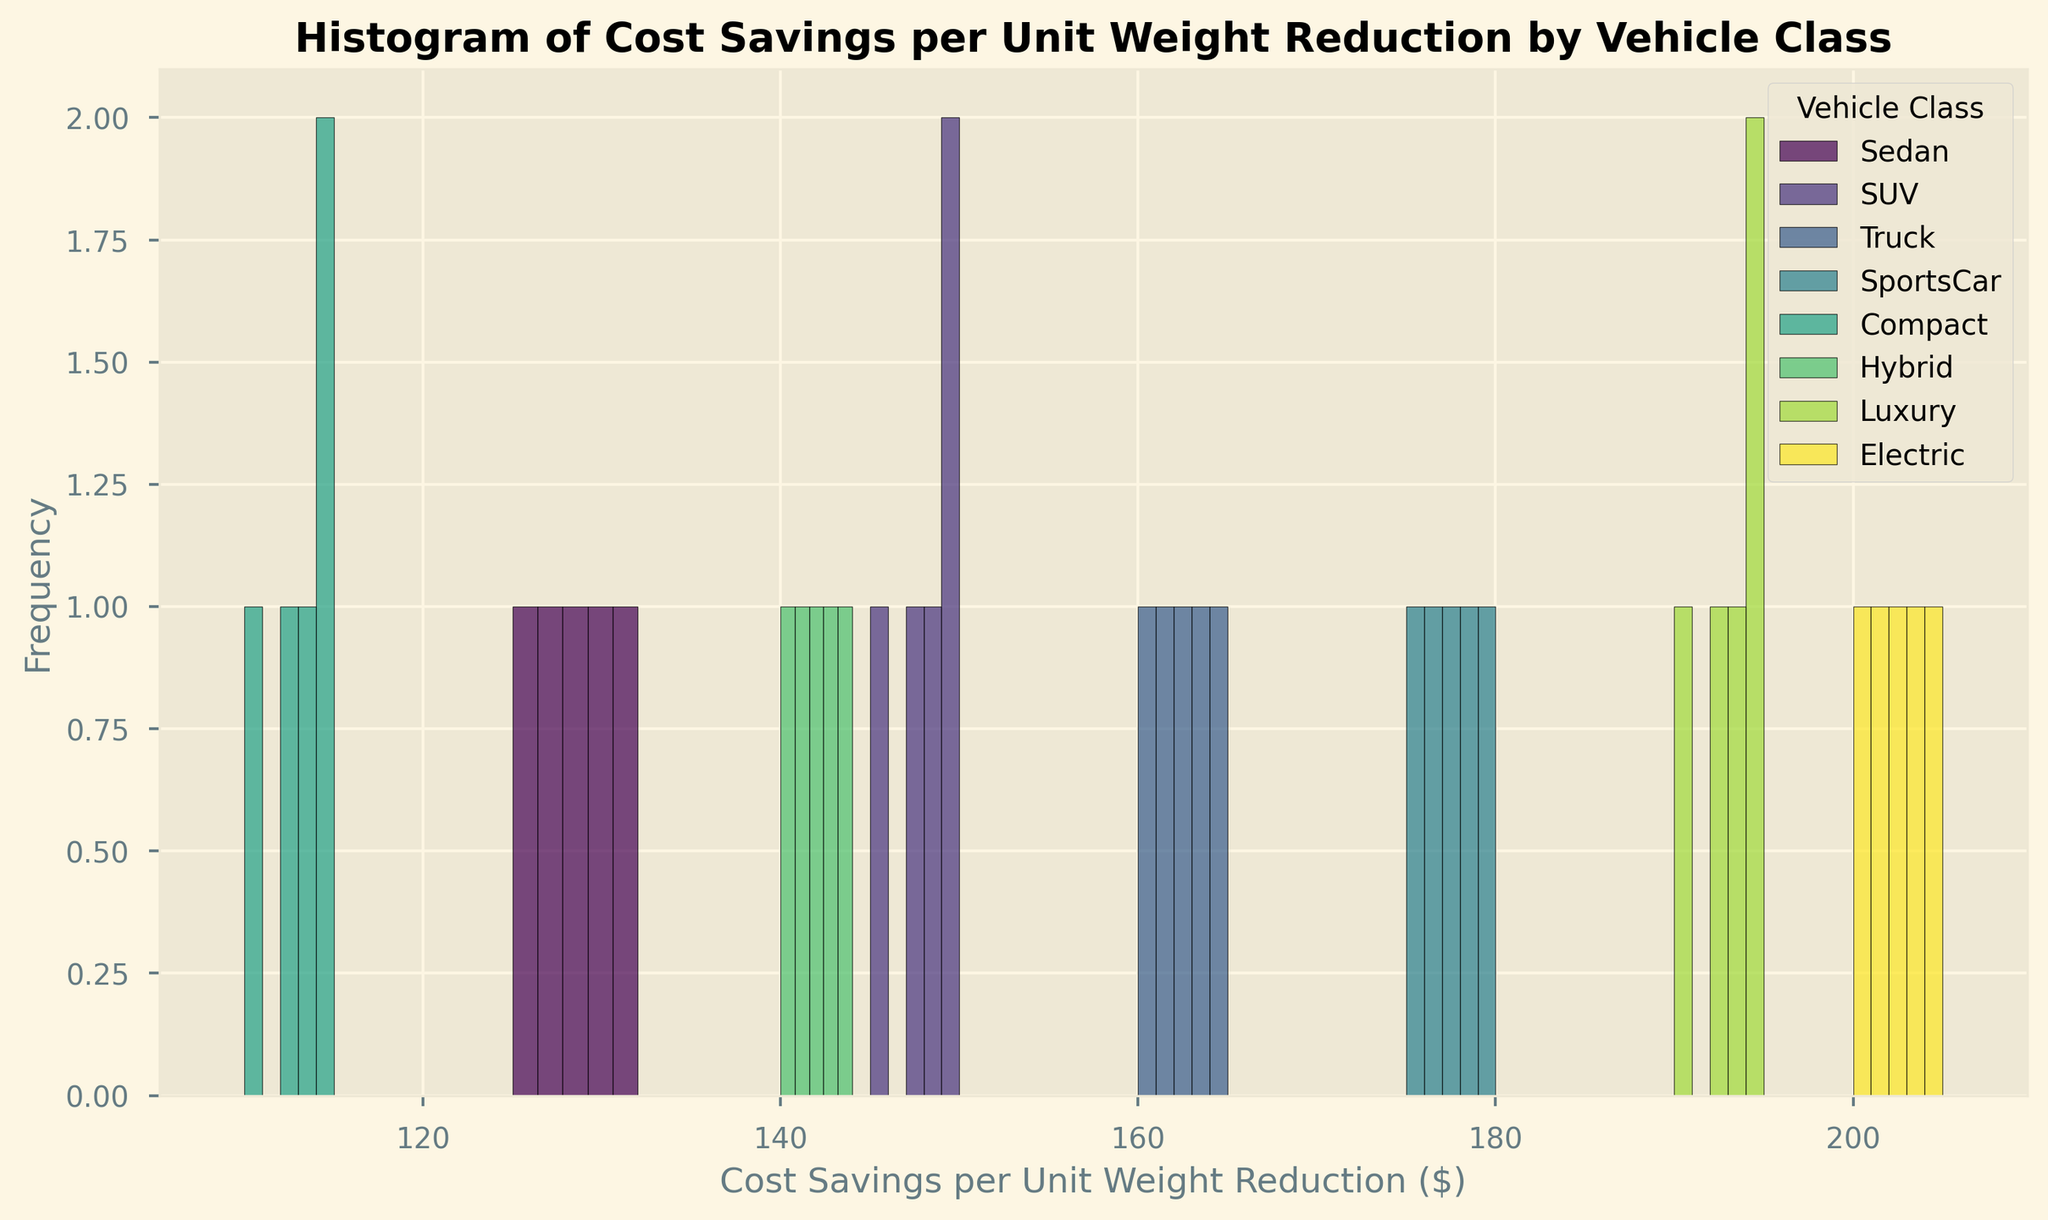What vehicle class demonstrates the highest cost savings per unit weight reduction? By examining the histogram, the Electric vehicle class shows the highest cost savings with a range around $200-$205.
Answer: Electric Which vehicle class has the most frequent cost savings range of $145-$150? The histogram shows the SUV class with the highest frequency in the $145-$150 range.
Answer: SUV How does the cost savings frequency for Hybrids compare to that of Compacts? Observing the histograms, the frequency of the cost savings for Hybrids in the ranges displayed is slightly higher compared to Compacts.
Answer: Hybrids Which vehicle class has the lowest cost savings range? By looking at the histogram, the Compact vehicle class demonstrates the lowest cost savings range around $110-$115.
Answer: Compact How many vehicle classes have their cost savings ranges below $150? By examining the histogram, three vehicle classes (Sedan, Compact, and Hybrid) have the majority of their cost savings below $150.
Answer: 3 What is the difference between the maximum cost savings in the Sedan class and the Electric class? The maximum cost savings in the Sedan class is $132, and for the Electric class, it's $205. The difference is $205 - $132 = $73.
Answer: $73 Which vehicle class has the most spread in terms of cost savings per unit weight reduction? By looking at the width of the histograms, the Truck class has a broader range, indicating a more spread-out cost savings distribution.
Answer: Truck What is the approximate frequency of the cost savings range $160-$165 for Trucks? In the histogram for Trucks, the frequency for the cost savings range $160-$165 is around 1-2.
Answer: 1-2 Are there any overlaps in cost savings ranges between SUVs and Hybrids? Both SUVs and Hybrids show some overlap in the cost savings ranges around $140-$150, indicating some similarities.
Answer: Yes 